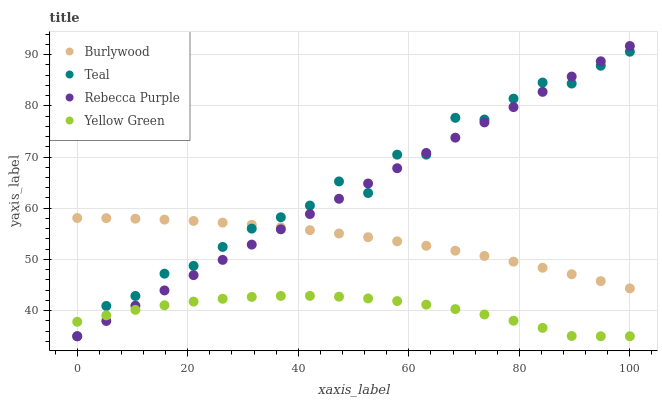Does Yellow Green have the minimum area under the curve?
Answer yes or no. Yes. Does Teal have the maximum area under the curve?
Answer yes or no. Yes. Does Rebecca Purple have the minimum area under the curve?
Answer yes or no. No. Does Rebecca Purple have the maximum area under the curve?
Answer yes or no. No. Is Rebecca Purple the smoothest?
Answer yes or no. Yes. Is Teal the roughest?
Answer yes or no. Yes. Is Teal the smoothest?
Answer yes or no. No. Is Rebecca Purple the roughest?
Answer yes or no. No. Does Rebecca Purple have the lowest value?
Answer yes or no. Yes. Does Rebecca Purple have the highest value?
Answer yes or no. Yes. Does Teal have the highest value?
Answer yes or no. No. Is Yellow Green less than Burlywood?
Answer yes or no. Yes. Is Burlywood greater than Yellow Green?
Answer yes or no. Yes. Does Teal intersect Yellow Green?
Answer yes or no. Yes. Is Teal less than Yellow Green?
Answer yes or no. No. Is Teal greater than Yellow Green?
Answer yes or no. No. Does Yellow Green intersect Burlywood?
Answer yes or no. No. 